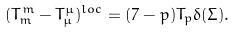Convert formula to latex. <formula><loc_0><loc_0><loc_500><loc_500>( T _ { m } ^ { m } - T _ { \mu } ^ { \mu } ) ^ { l o c } = ( 7 - p ) T _ { p } \delta ( \Sigma ) .</formula> 